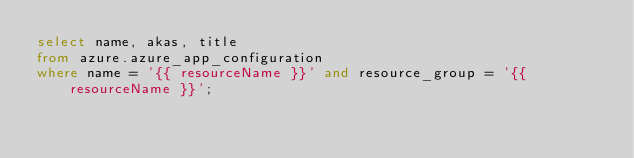Convert code to text. <code><loc_0><loc_0><loc_500><loc_500><_SQL_>select name, akas, title
from azure.azure_app_configuration
where name = '{{ resourceName }}' and resource_group = '{{ resourceName }}';
</code> 